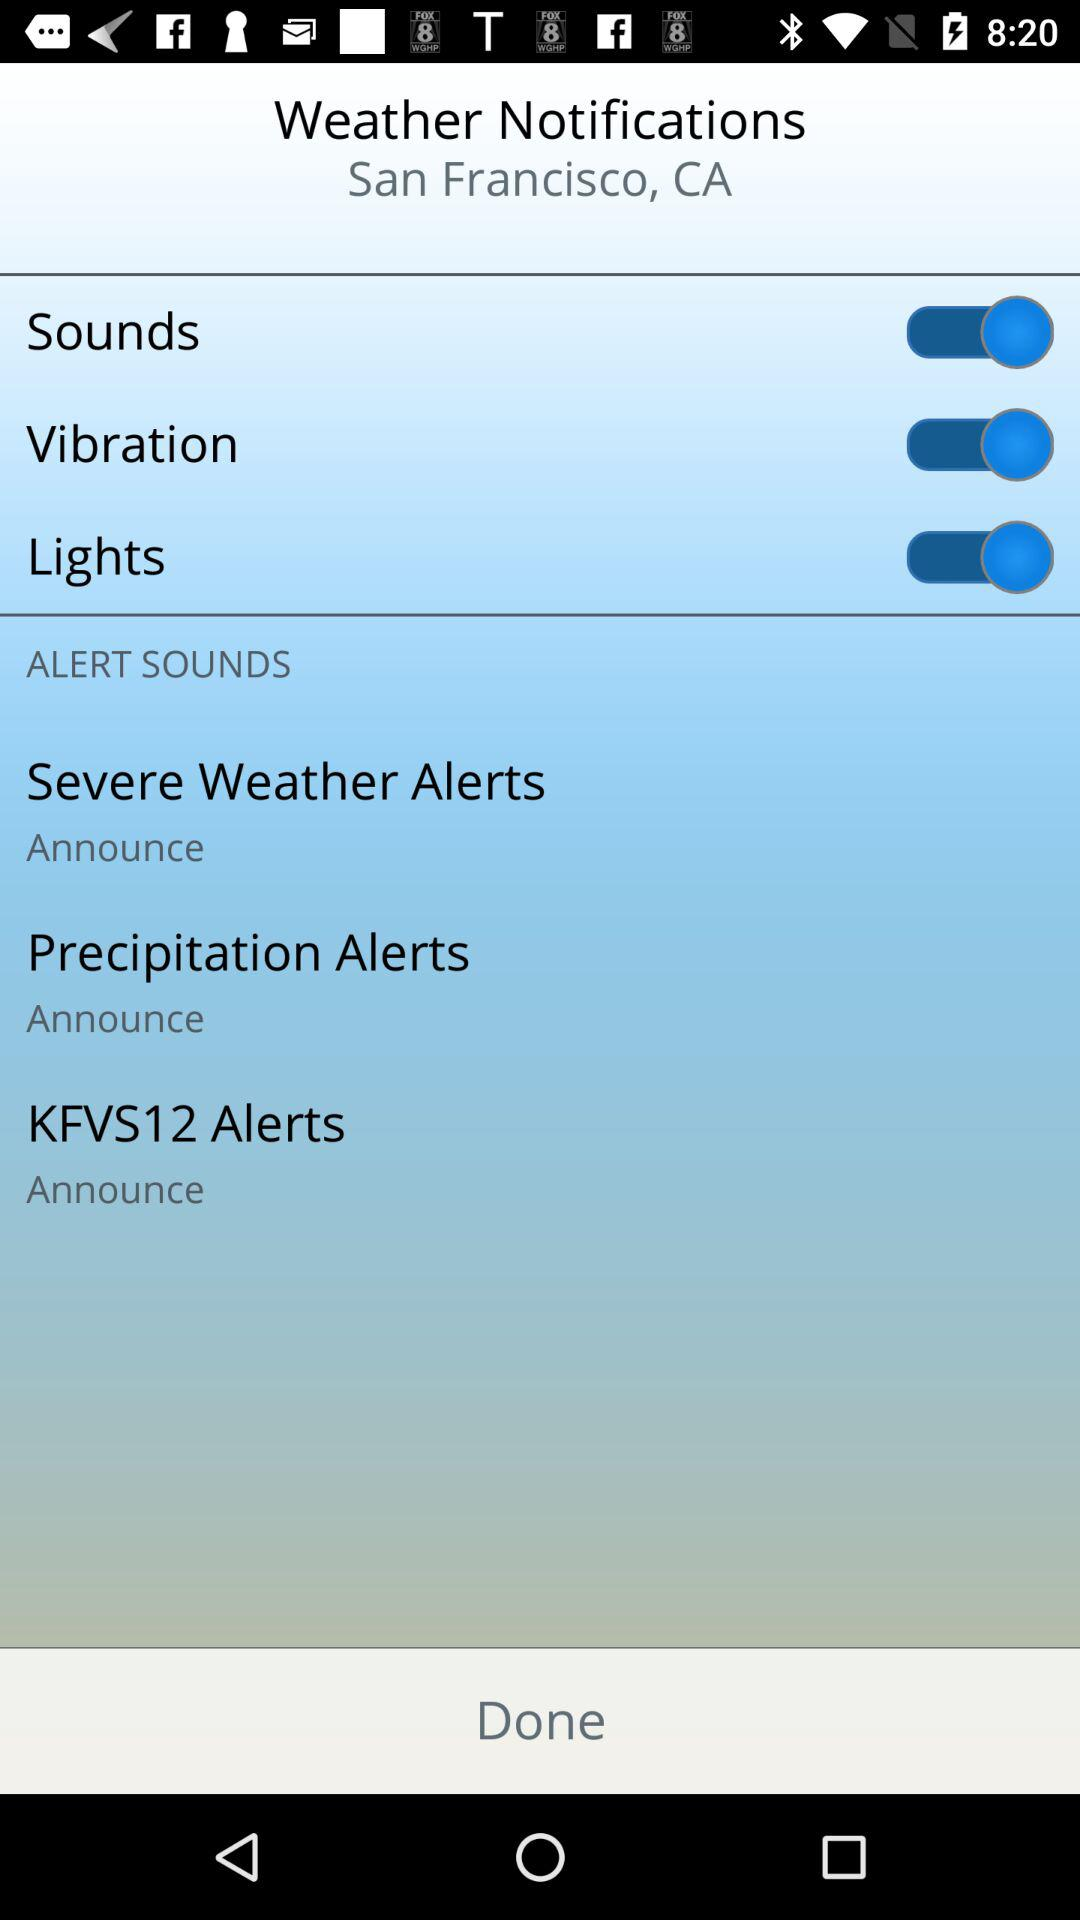What's the location? The location is San Francisco, CA. 